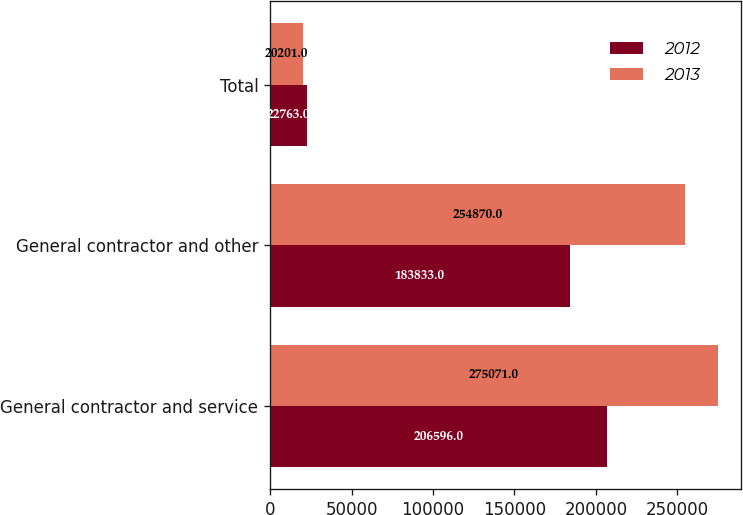Convert chart. <chart><loc_0><loc_0><loc_500><loc_500><stacked_bar_chart><ecel><fcel>General contractor and service<fcel>General contractor and other<fcel>Total<nl><fcel>2012<fcel>206596<fcel>183833<fcel>22763<nl><fcel>2013<fcel>275071<fcel>254870<fcel>20201<nl></chart> 